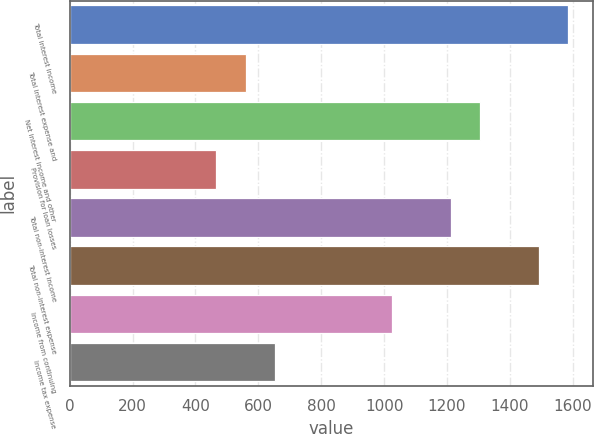Convert chart to OTSL. <chart><loc_0><loc_0><loc_500><loc_500><bar_chart><fcel>Total interest income<fcel>Total interest expense and<fcel>Net interest income and other<fcel>Provision for loan losses<fcel>Total non-interest income<fcel>Total non-interest expense<fcel>Income from continuing<fcel>Income tax expense<nl><fcel>1585.99<fcel>559.8<fcel>1306.12<fcel>466.51<fcel>1212.83<fcel>1492.7<fcel>1026.25<fcel>653.09<nl></chart> 